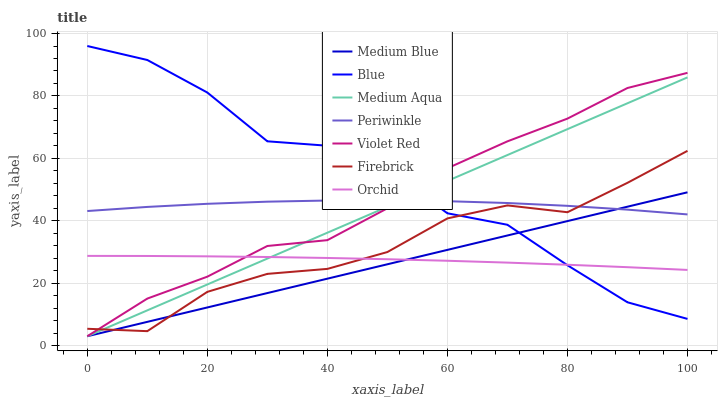Does Medium Blue have the minimum area under the curve?
Answer yes or no. Yes. Does Blue have the maximum area under the curve?
Answer yes or no. Yes. Does Violet Red have the minimum area under the curve?
Answer yes or no. No. Does Violet Red have the maximum area under the curve?
Answer yes or no. No. Is Medium Blue the smoothest?
Answer yes or no. Yes. Is Blue the roughest?
Answer yes or no. Yes. Is Violet Red the smoothest?
Answer yes or no. No. Is Violet Red the roughest?
Answer yes or no. No. Does Violet Red have the lowest value?
Answer yes or no. Yes. Does Firebrick have the lowest value?
Answer yes or no. No. Does Blue have the highest value?
Answer yes or no. Yes. Does Violet Red have the highest value?
Answer yes or no. No. Is Orchid less than Periwinkle?
Answer yes or no. Yes. Is Periwinkle greater than Orchid?
Answer yes or no. Yes. Does Medium Blue intersect Orchid?
Answer yes or no. Yes. Is Medium Blue less than Orchid?
Answer yes or no. No. Is Medium Blue greater than Orchid?
Answer yes or no. No. Does Orchid intersect Periwinkle?
Answer yes or no. No. 